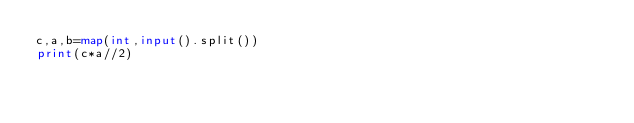Convert code to text. <code><loc_0><loc_0><loc_500><loc_500><_Python_>c,a,b=map(int,input().split())
print(c*a//2)</code> 